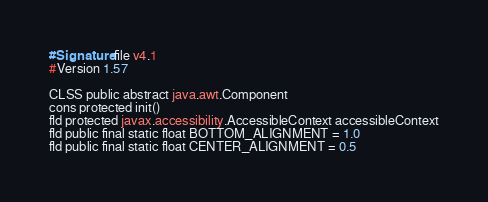Convert code to text. <code><loc_0><loc_0><loc_500><loc_500><_SML_>#Signature file v4.1
#Version 1.57

CLSS public abstract java.awt.Component
cons protected init()
fld protected javax.accessibility.AccessibleContext accessibleContext
fld public final static float BOTTOM_ALIGNMENT = 1.0
fld public final static float CENTER_ALIGNMENT = 0.5</code> 